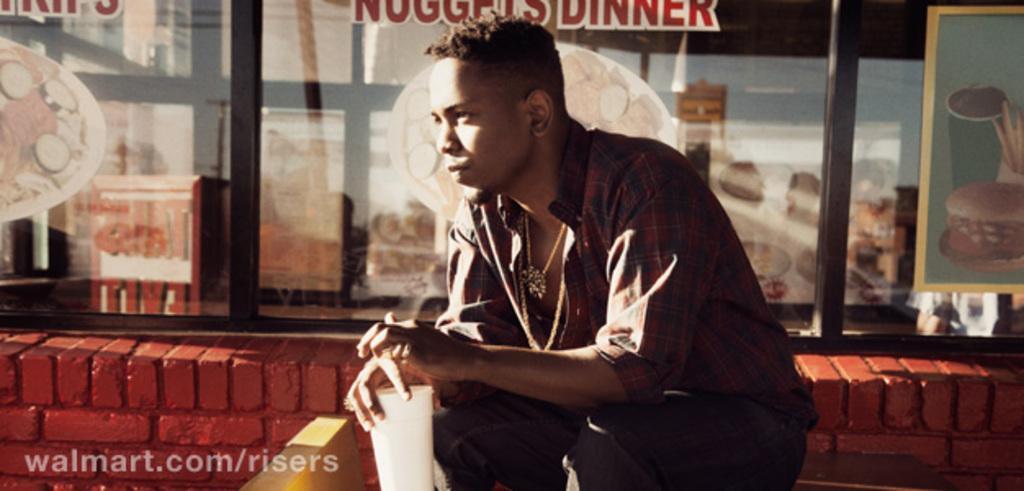Can you describe this image briefly? In the center of the image a man is sitting and holding a glass. In the background of the image window is there. On the left side of the image wall is present. 